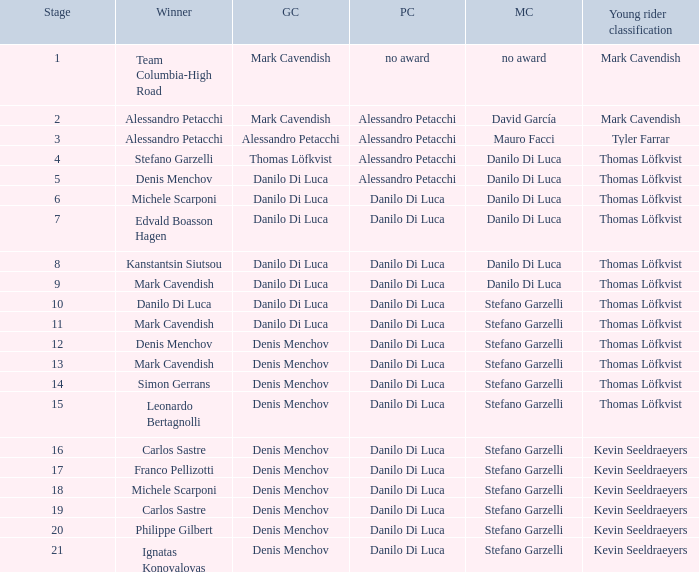When 19 is the stage who is the points classification? Danilo Di Luca. 